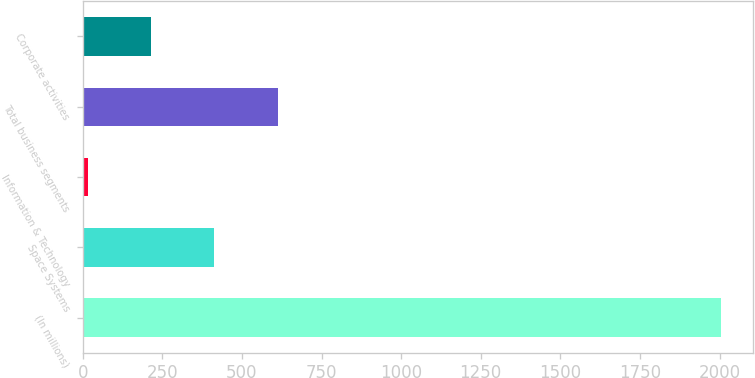Convert chart to OTSL. <chart><loc_0><loc_0><loc_500><loc_500><bar_chart><fcel>(In millions)<fcel>Space Systems<fcel>Information & Technology<fcel>Total business segments<fcel>Corporate activities<nl><fcel>2004<fcel>413.6<fcel>16<fcel>612.4<fcel>214.8<nl></chart> 